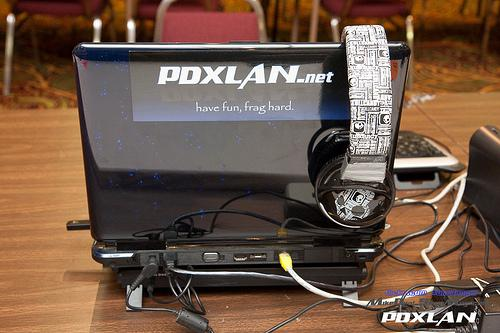Question: who is in the photo?
Choices:
A. 1 person.
B. 2 people.
C. 3 people.
D. Noone.
Answer with the letter. Answer: D Question: what is this item?
Choices:
A. Steam-powered.
B. Solar-powered.
C. Electronic.
D. Manual.
Answer with the letter. Answer: C Question: where is item sitting?
Choices:
A. On the table.
B. On the shelf.
C. On desk.
D. On the counter.
Answer with the letter. Answer: C 